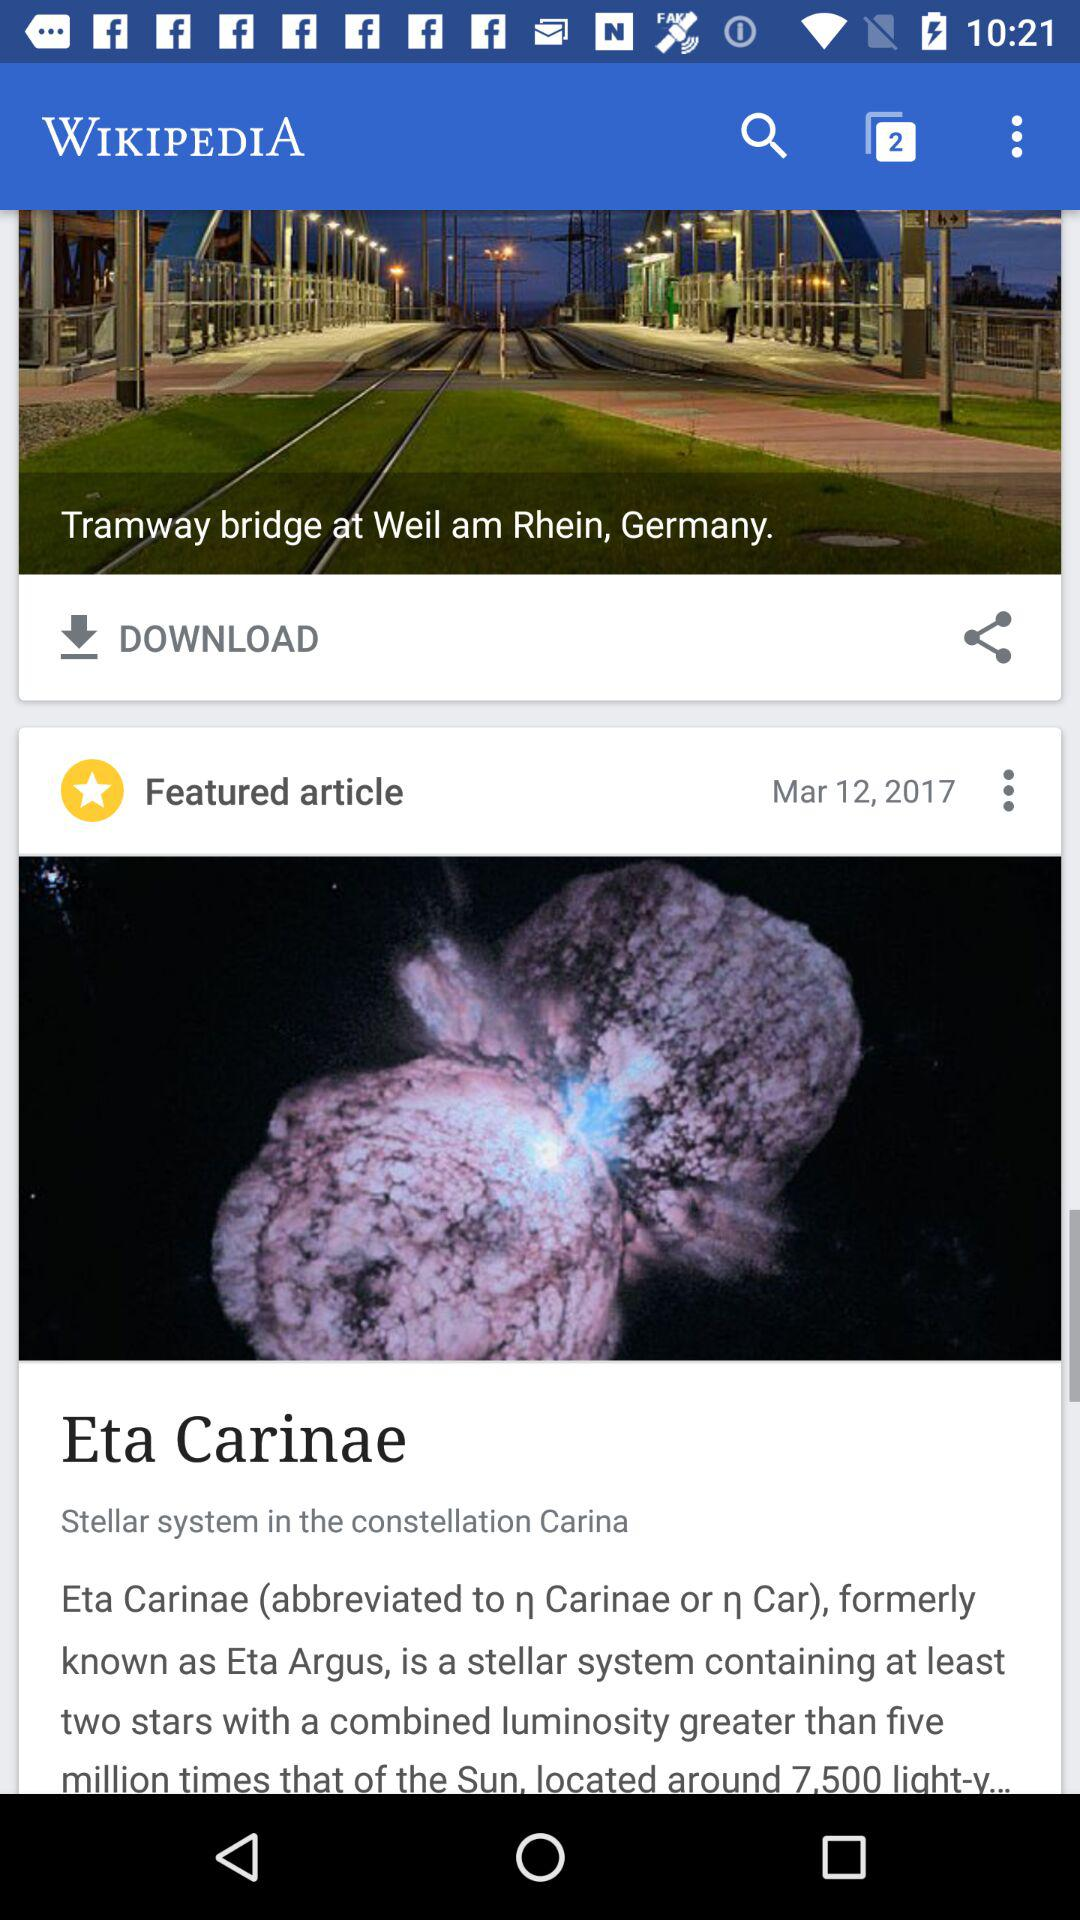How many articles have been downloaded?
When the provided information is insufficient, respond with <no answer>. <no answer> 